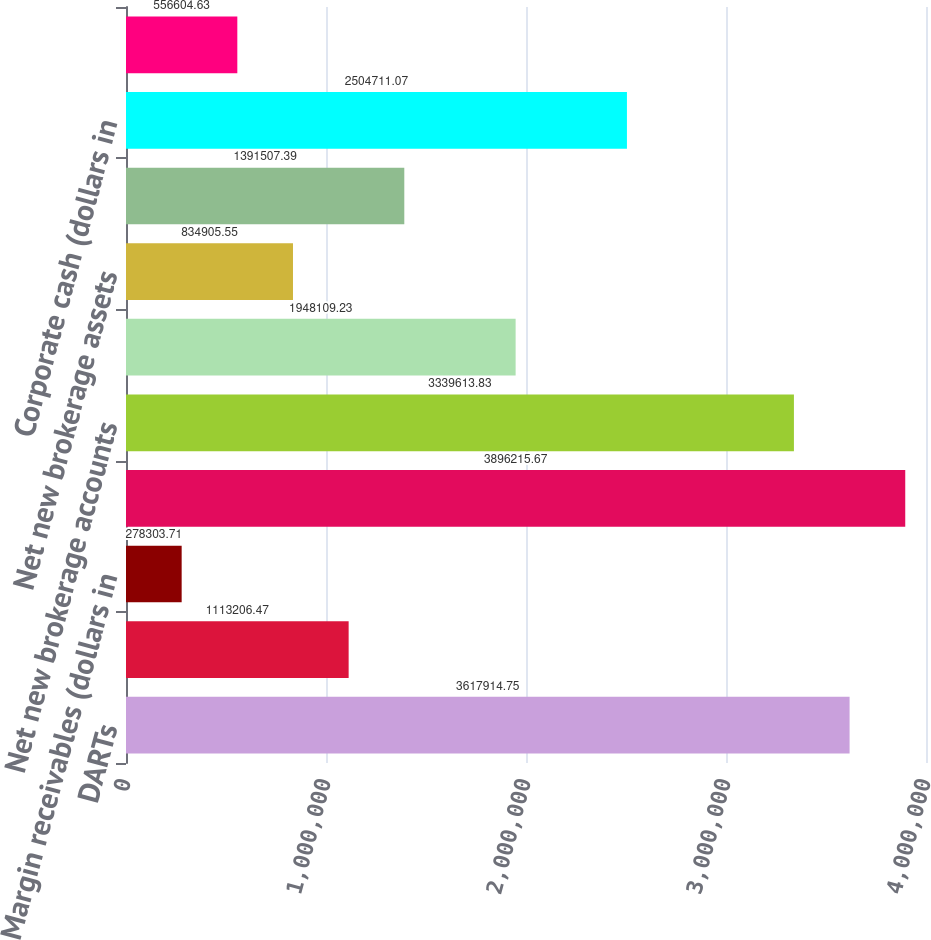Convert chart. <chart><loc_0><loc_0><loc_500><loc_500><bar_chart><fcel>DARTs<fcel>Average commission per trade<fcel>Margin receivables (dollars in<fcel>End of period brokerage<fcel>Net new brokerage accounts<fcel>Customer assets (dollars in<fcel>Net new brokerage assets<fcel>Brokerage related cash<fcel>Corporate cash (dollars in<fcel>ETRADE Bank Tier 1 leverage<nl><fcel>3.61791e+06<fcel>1.11321e+06<fcel>278304<fcel>3.89622e+06<fcel>3.33961e+06<fcel>1.94811e+06<fcel>834906<fcel>1.39151e+06<fcel>2.50471e+06<fcel>556605<nl></chart> 